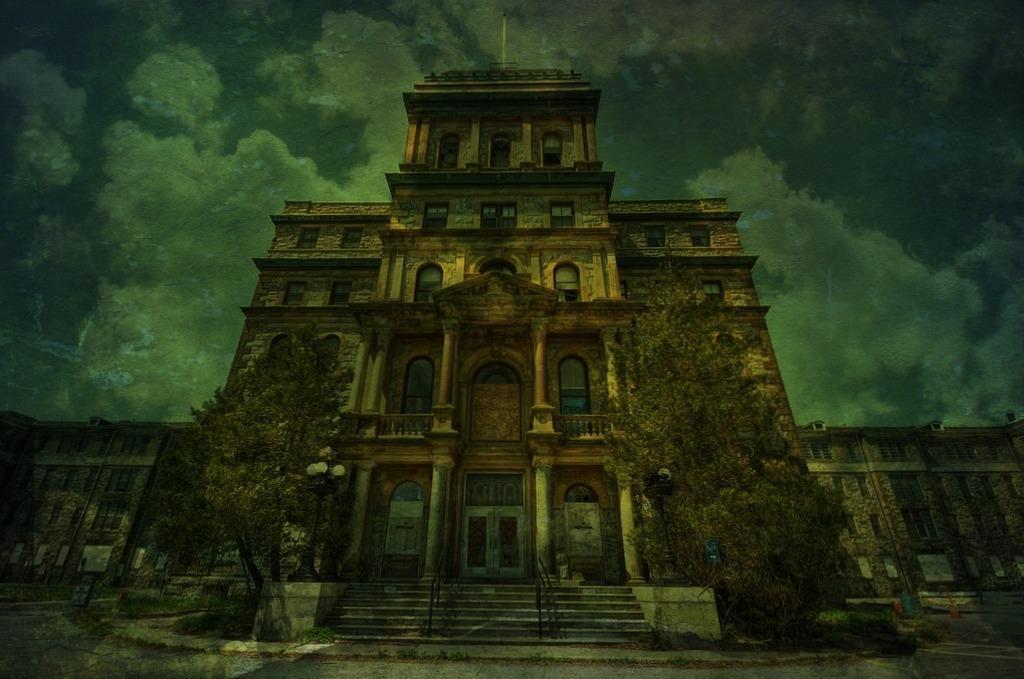In one or two sentences, can you explain what this image depicts? In the middle of this image, there is a building which is having windows and doors. Beside this building, there are two trees on the ground. In the background, there are other buildings on the ground and there are clouds in the sky. 